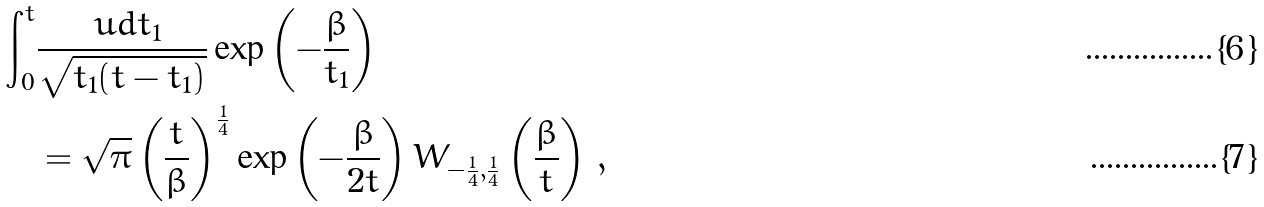<formula> <loc_0><loc_0><loc_500><loc_500>\int _ { 0 } ^ { t } & \frac { \ u d t _ { 1 } } { \sqrt { t _ { 1 } ( t - t _ { 1 } ) } } \exp \left ( - \frac { \beta } { t _ { 1 } } \right ) \\ & = \sqrt { \pi } \left ( \frac { t } { \beta } \right ) ^ { \frac { 1 } { 4 } } \exp \left ( - \frac { \beta } { 2 t } \right ) W _ { - \frac { 1 } { 4 } , \frac { 1 } { 4 } } \left ( \frac { \beta } { t } \right ) \, ,</formula> 